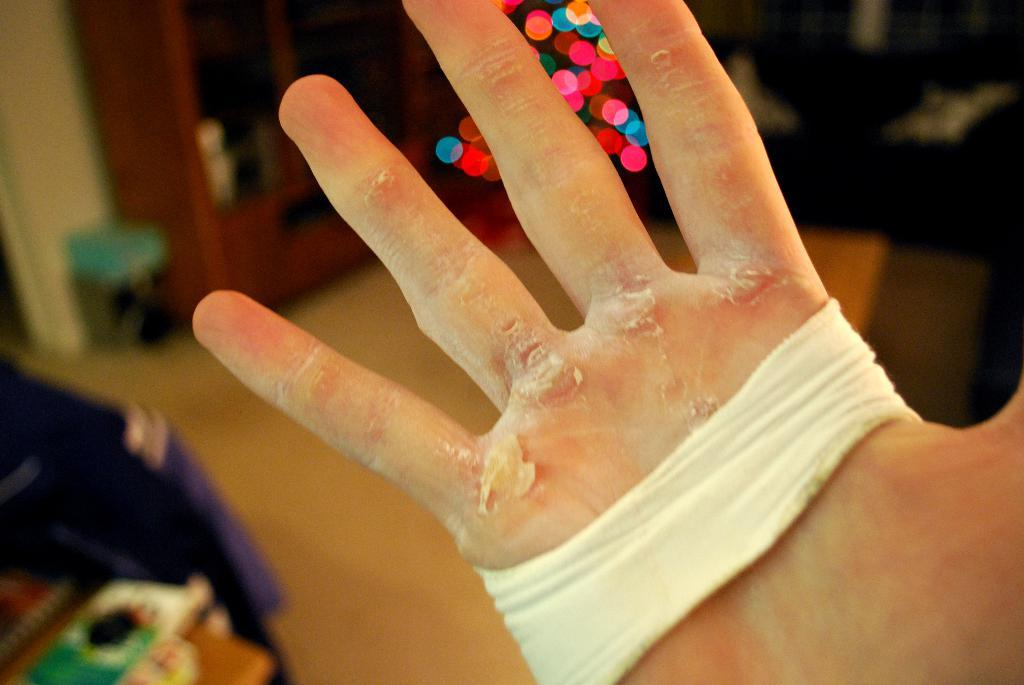What part of a person's body is visible in the image? There is a person's hand in the image. Can you describe the condition of the hand? The hand appears to be fully injured. What type of plantation can be seen in the background of the image? There is no plantation visible in the image; it only shows a person's hand. Is the person in the image sleeping or awake? The image only shows a person's hand, so it cannot be determined if the person is sleeping or awake. 